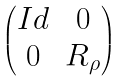<formula> <loc_0><loc_0><loc_500><loc_500>\begin{pmatrix} I d & 0 \\ 0 & R _ { \rho } \end{pmatrix}</formula> 